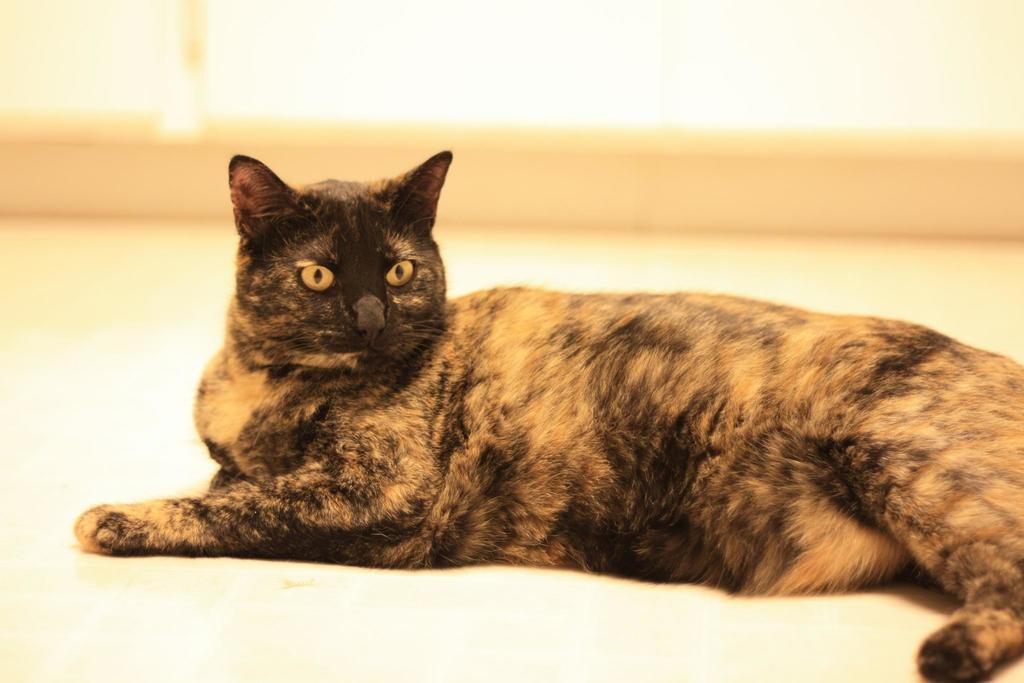Describe this image in one or two sentences. In this image there is a cat truncated towards the right of the image, there is the floor truncated towards the bottom of the image, there is the wall truncated, there are curtains truncated towards the top of the image. 